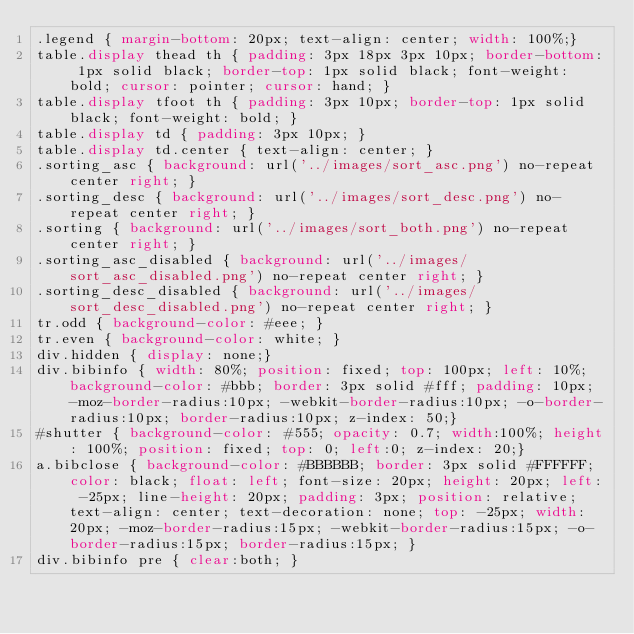<code> <loc_0><loc_0><loc_500><loc_500><_CSS_>.legend { margin-bottom: 20px; text-align: center; width: 100%;}
table.display thead th { padding: 3px 18px 3px 10px; border-bottom: 1px solid black; border-top: 1px solid black; font-weight: bold; cursor: pointer; cursor: hand; }
table.display tfoot th { padding: 3px 10px; border-top: 1px solid black; font-weight: bold; }
table.display td { padding: 3px 10px; }
table.display td.center { text-align: center; }
.sorting_asc { background: url('../images/sort_asc.png') no-repeat center right; }
.sorting_desc { background: url('../images/sort_desc.png') no-repeat center right; }
.sorting { background: url('../images/sort_both.png') no-repeat center right; }
.sorting_asc_disabled { background: url('../images/sort_asc_disabled.png') no-repeat center right; }
.sorting_desc_disabled { background: url('../images/sort_desc_disabled.png') no-repeat center right; }
tr.odd { background-color: #eee; }
tr.even { background-color: white; }
div.hidden { display: none;}
div.bibinfo { width: 80%; position: fixed; top: 100px; left: 10%; background-color: #bbb; border: 3px solid #fff; padding: 10px; -moz-border-radius:10px; -webkit-border-radius:10px; -o-border-radius:10px; border-radius:10px; z-index: 50;}
#shutter { background-color: #555; opacity: 0.7; width:100%; height: 100%; position: fixed; top: 0; left:0; z-index: 20;}
a.bibclose { background-color: #BBBBBB; border: 3px solid #FFFFFF; color: black; float: left; font-size: 20px; height: 20px; left: -25px; line-height: 20px; padding: 3px; position: relative; text-align: center; text-decoration: none; top: -25px; width: 20px; -moz-border-radius:15px; -webkit-border-radius:15px; -o-border-radius:15px; border-radius:15px; }
div.bibinfo pre { clear:both; }
</code> 